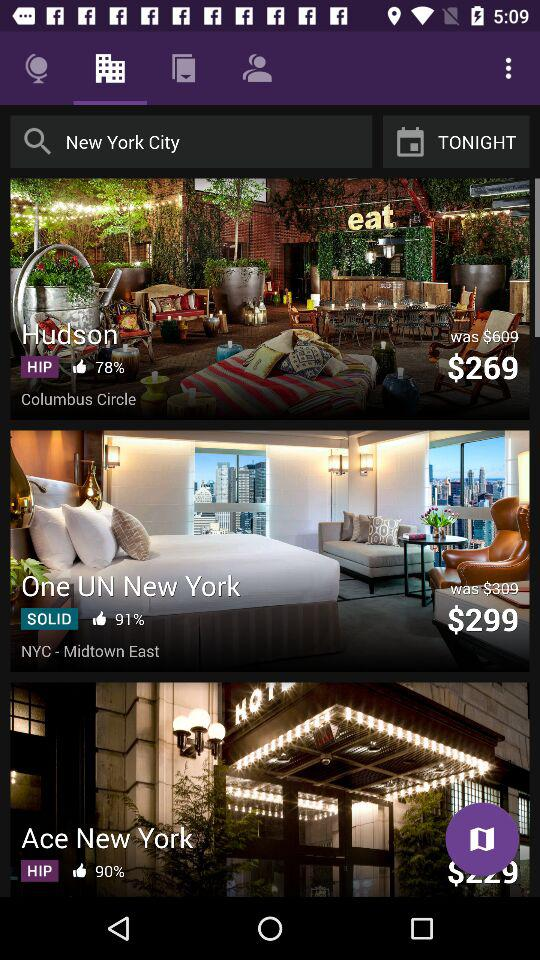What is the location of the Hudson Hotel? The location is Columbus Circle. 